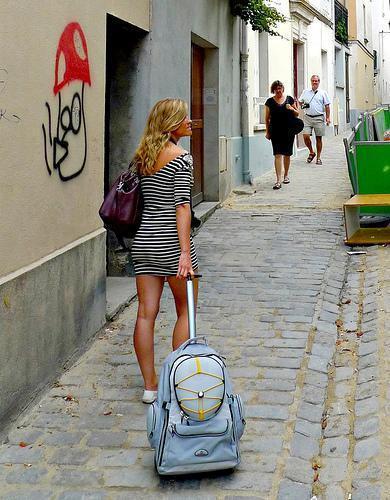How many people are in this photo?
Give a very brief answer. 3. 